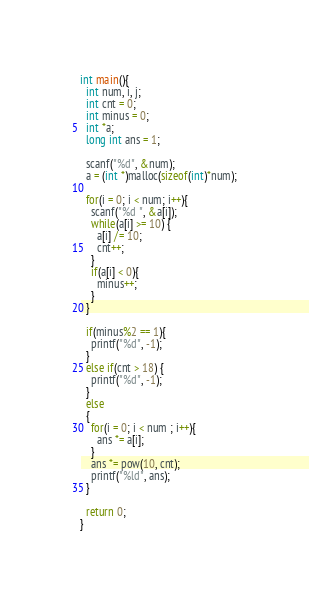Convert code to text. <code><loc_0><loc_0><loc_500><loc_500><_C_>int main(){
  int num, i, j;
  int cnt = 0;
  int minus = 0;
  int *a;
  long int ans = 1;
  
  scanf("%d", &num);
  a = (int *)malloc(sizeof(int)*num);
  
  for(i = 0; i < num; i++){
    scanf("%d ", &a[i]);
    while(a[i] >= 10) {
      a[i] /= 10;
      cnt++;
    }
    if(a[i] < 0){
      minus++;
    }
  }
  
  if(minus%2 == 1){
    printf("%d", -1);
  }
  else if(cnt > 18) {
    printf("%d", -1);
  }
  else
  {
    for(i = 0; i < num ; i++){
      ans *= a[i];
    }
    ans *= pow(10, cnt);
    printf("%ld", ans);
  }
  
  return 0;
}</code> 